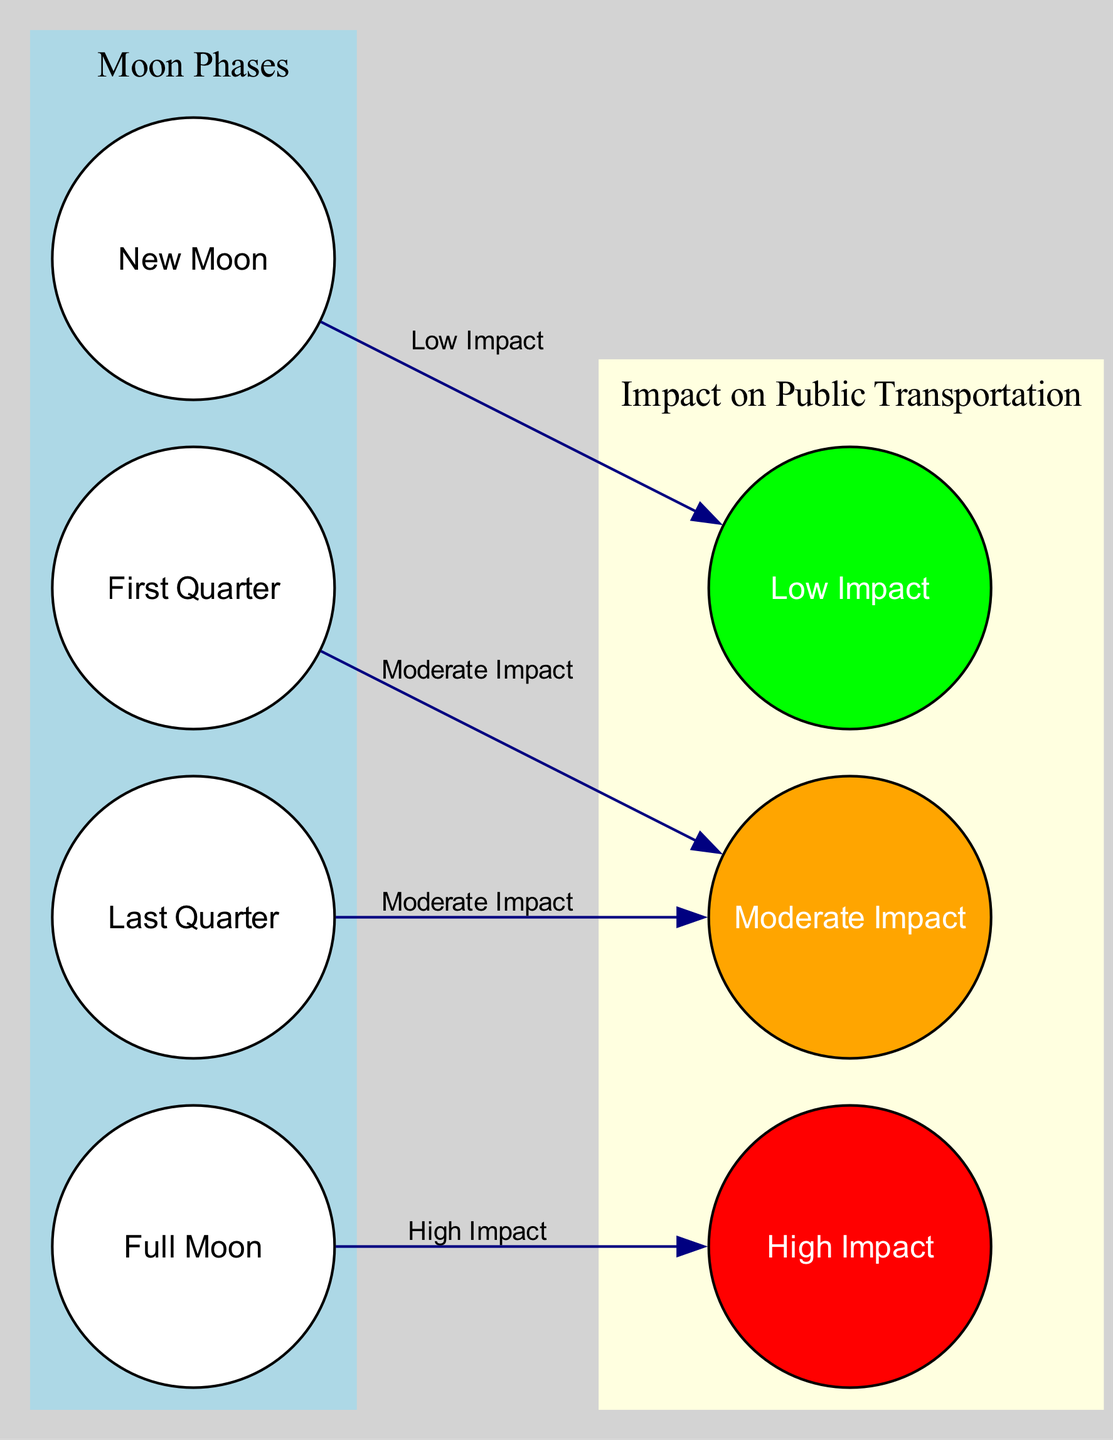What is the effect of a full moon on public transportation in Bern? A full moon is connected to the "High Impact" node, which indicates significant delays in public transportation. This is indicated by the edge connecting the "full moon" node to the "impact high" node.
Answer: High Impact How many phases of the moon are represented in the diagram? The diagram includes four moon phases: New Moon, First Quarter, Full Moon, and Last Quarter. By counting the nodes designated as moon phases, we find there are four total.
Answer: Four What kind of impact is associated with the last quarter phase of the moon? The last quarter phase is related to the "Moderate Impact" node, indicated by the edge connecting "last quarter" to "impact moderate," which signifies minor delays in transportation.
Answer: Moderate Impact Which phase of the moon has no visible effect on public transportation timings? The new moon is linked to the "Low Impact" node, showing that it has no significant effect on public transportation timings. This connection indicates that during a new moon, transportation timings remain normal.
Answer: Low Impact How do the impacts differ between the first quarter and last quarter moon phases? Both the first quarter and last quarter phases are connected to the "Moderate Impact" node, indicating that both phases cause minor delays in transportation. Therefore, the impact level is the same for both phases.
Answer: Same Impact Level What color represents the "High Impact" node in the diagram? The "High Impact" node is colored red, as specified by the node's color attribute, indicating significant delays in public transportation timings associated with the full moon.
Answer: Red What is the total number of edges in the diagram? By counting the connections, we see that there are four edges: one from "new moon" to "impact low," one from "first quarter" to "impact moderate," one from "full moon" to "impact high," and one from "last quarter" to "impact moderate." Thus, the total number of edges is four.
Answer: Four What do the colors signify for the impact nodes in the diagram? The colors represent varying levels of impact on public transportation: green for "Low Impact," orange for "Moderate Impact," and red for "High Impact." Each color distinction helps visualize the severity of delays experienced during different moon phases.
Answer: Different Impact Levels 